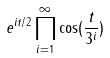<formula> <loc_0><loc_0><loc_500><loc_500>e ^ { i t / 2 } \prod _ { i = 1 } ^ { \infty } \cos ( \frac { t } { 3 ^ { i } } )</formula> 